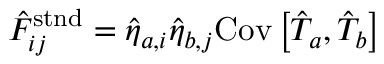<formula> <loc_0><loc_0><loc_500><loc_500>\begin{array} { r } { \hat { F } _ { i j } ^ { s t n d } = \hat { \eta } _ { a , i } \hat { \eta } _ { b , j } C o v \left [ \hat { T } _ { a } , \hat { T } _ { b } \right ] } \end{array}</formula> 